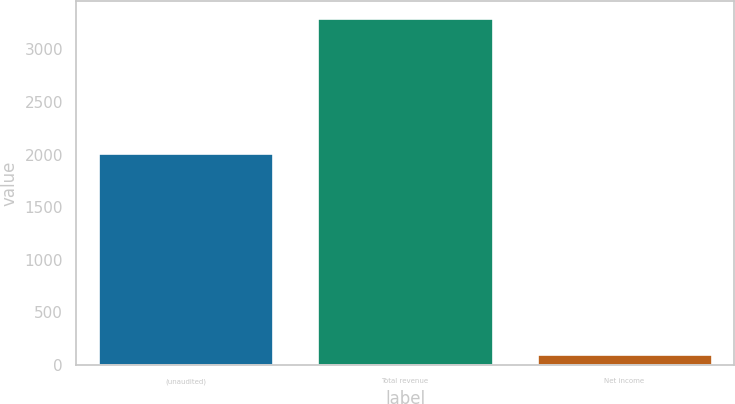Convert chart to OTSL. <chart><loc_0><loc_0><loc_500><loc_500><bar_chart><fcel>(unaudited)<fcel>Total revenue<fcel>Net income<nl><fcel>2015<fcel>3297.7<fcel>107.6<nl></chart> 